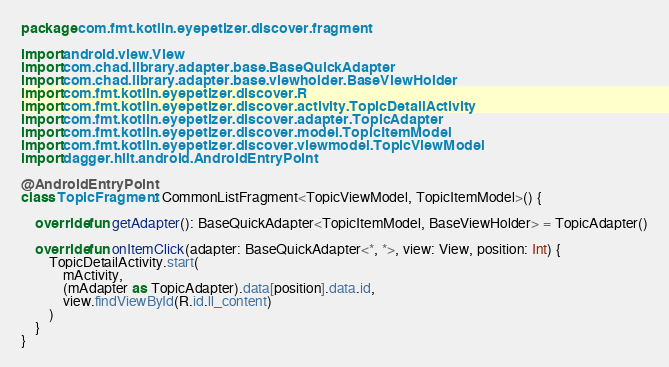<code> <loc_0><loc_0><loc_500><loc_500><_Kotlin_>package com.fmt.kotlin.eyepetizer.discover.fragment

import android.view.View
import com.chad.library.adapter.base.BaseQuickAdapter
import com.chad.library.adapter.base.viewholder.BaseViewHolder
import com.fmt.kotlin.eyepetizer.discover.R
import com.fmt.kotlin.eyepetizer.discover.activity.TopicDetailActivity
import com.fmt.kotlin.eyepetizer.discover.adapter.TopicAdapter
import com.fmt.kotlin.eyepetizer.discover.model.TopicItemModel
import com.fmt.kotlin.eyepetizer.discover.viewmodel.TopicViewModel
import dagger.hilt.android.AndroidEntryPoint

@AndroidEntryPoint
class TopicFragment : CommonListFragment<TopicViewModel, TopicItemModel>() {

    override fun getAdapter(): BaseQuickAdapter<TopicItemModel, BaseViewHolder> = TopicAdapter()

    override fun onItemClick(adapter: BaseQuickAdapter<*, *>, view: View, position: Int) {
        TopicDetailActivity.start(
            mActivity,
            (mAdapter as TopicAdapter).data[position].data.id,
            view.findViewById(R.id.ll_content)
        )
    }
}</code> 